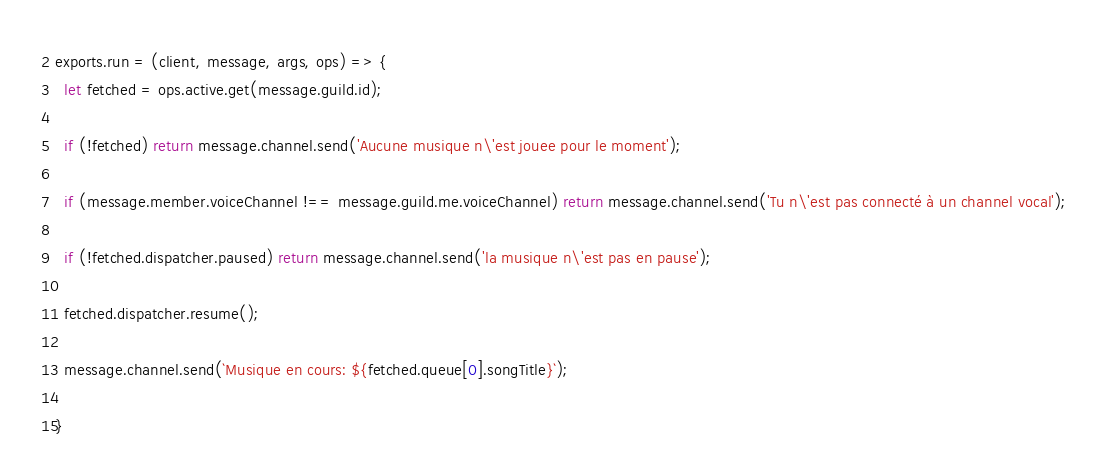Convert code to text. <code><loc_0><loc_0><loc_500><loc_500><_JavaScript_>exports.run = (client, message, args, ops) => {
  let fetched = ops.active.get(message.guild.id);
  
  if (!fetched) return message.channel.send('Aucune musique n\'est jouee pour le moment');
  
  if (message.member.voiceChannel !== message.guild.me.voiceChannel) return message.channel.send('Tu n\'est pas connecté à un channel vocal');
  
  if (!fetched.dispatcher.paused) return message.channel.send('la musique n\'est pas en pause');
  
  fetched.dispatcher.resume();
  
  message.channel.send(`Musique en cours: ${fetched.queue[0].songTitle}`);

}</code> 